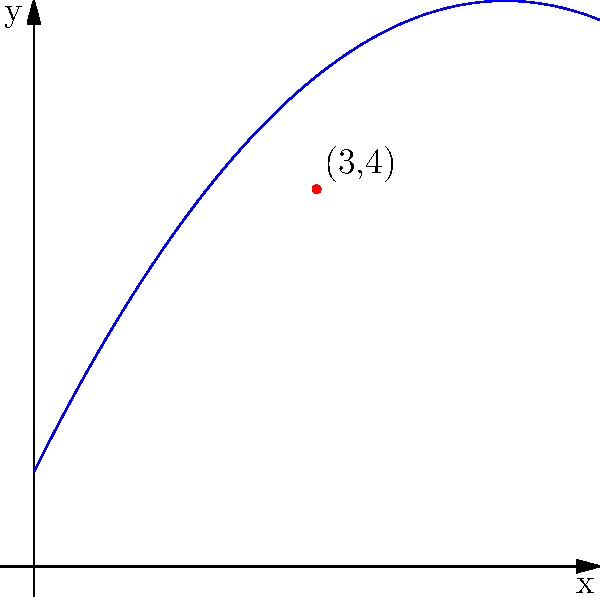As a magician, you've perfected the art of card throwing. The trajectory of one of your thrown cards can be modeled by the quadratic function $f(x) = -0.2x^2 + 2x + 1$, where $x$ is the horizontal distance and $f(x)$ is the height, both measured in meters. If the card passes through the point (3,4) on its path, what is the maximum height reached by the card? To find the maximum height of the card's trajectory, we need to follow these steps:

1) The general form of a quadratic function is $f(x) = -ax^2 + bx + c$, where the vertex form is $f(x) = -a(x-h)^2 + k$. Here, $(h,k)$ is the vertex of the parabola, which represents the maximum point for this downward-facing parabola.

2) From the given function $f(x) = -0.2x^2 + 2x + 1$, we can identify $a = 0.2$, $b = 2$, and $c = 1$.

3) To find the x-coordinate of the vertex, we use the formula $h = -\frac{b}{2a}$:

   $h = -\frac{2}{2(-0.2)} = -\frac{2}{-0.4} = 5$

4) To find the y-coordinate (maximum height), we substitute $x = 5$ into the original function:

   $f(5) = -0.2(5)^2 + 2(5) + 1$
         $= -0.2(25) + 10 + 1$
         $= -5 + 10 + 1$
         $= 6$

5) Therefore, the vertex of the parabola is at the point (5,6).

6) The y-coordinate of the vertex, 6 meters, represents the maximum height reached by the card.
Answer: 6 meters 